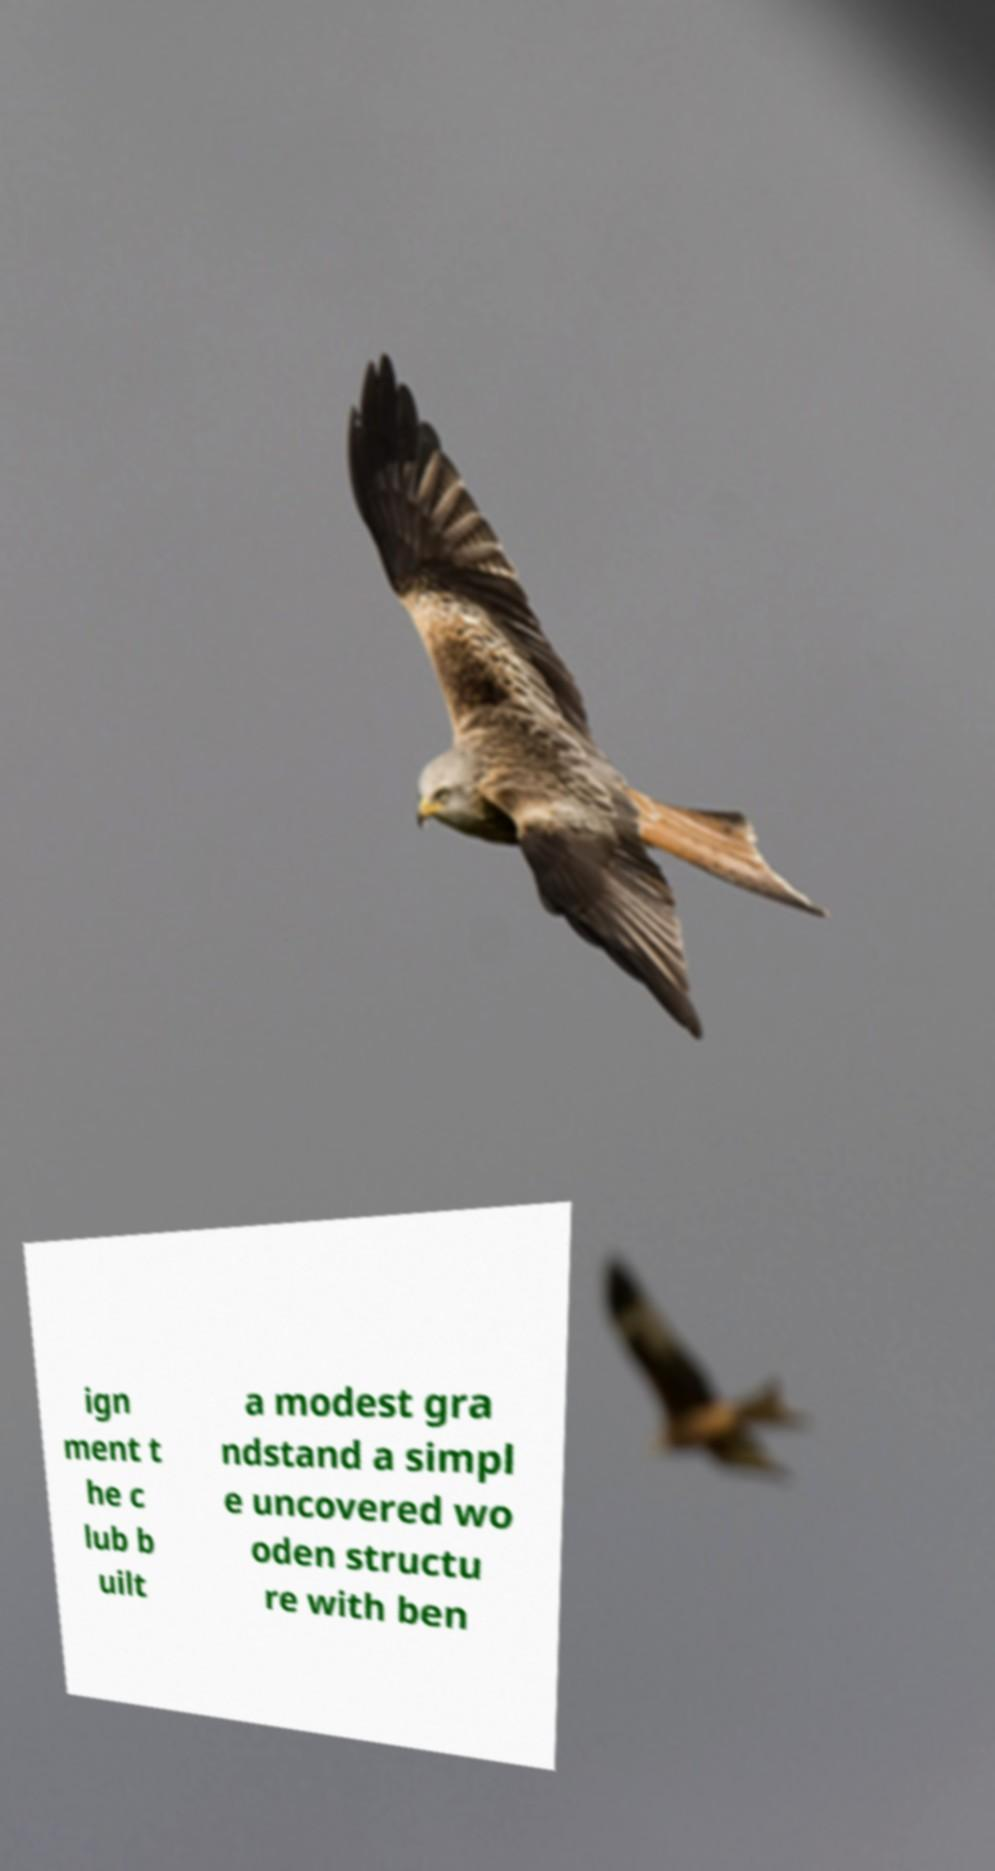There's text embedded in this image that I need extracted. Can you transcribe it verbatim? ign ment t he c lub b uilt a modest gra ndstand a simpl e uncovered wo oden structu re with ben 